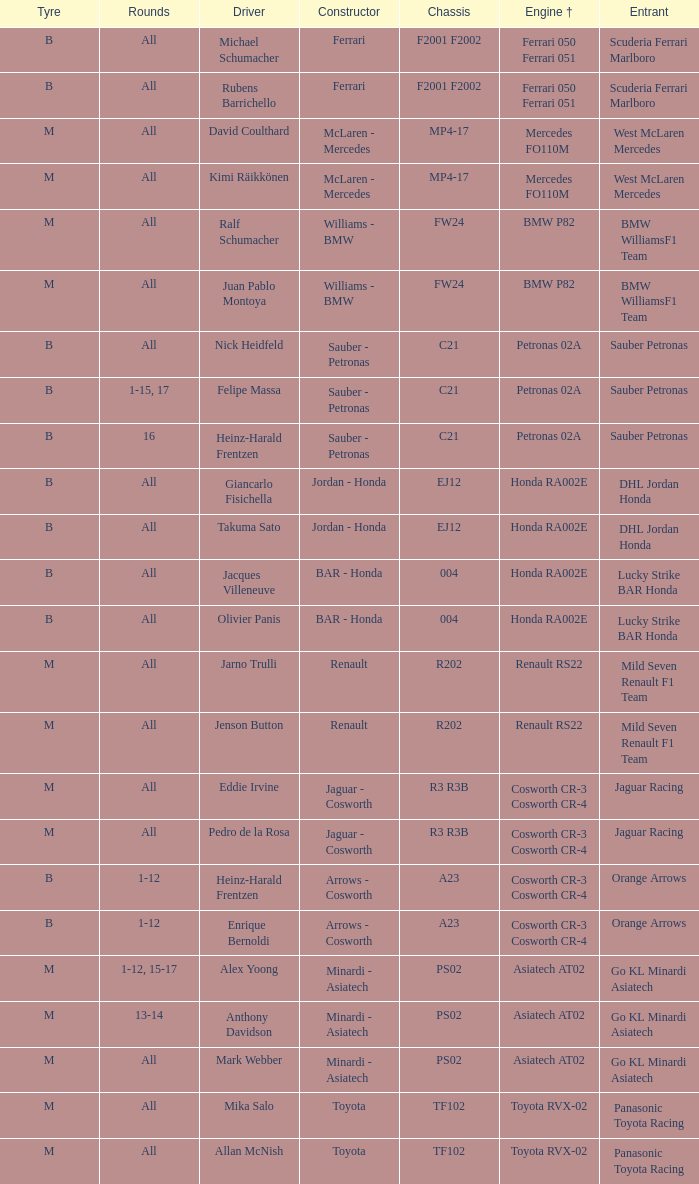Who is the entrant when the engine is bmw p82? BMW WilliamsF1 Team, BMW WilliamsF1 Team. 